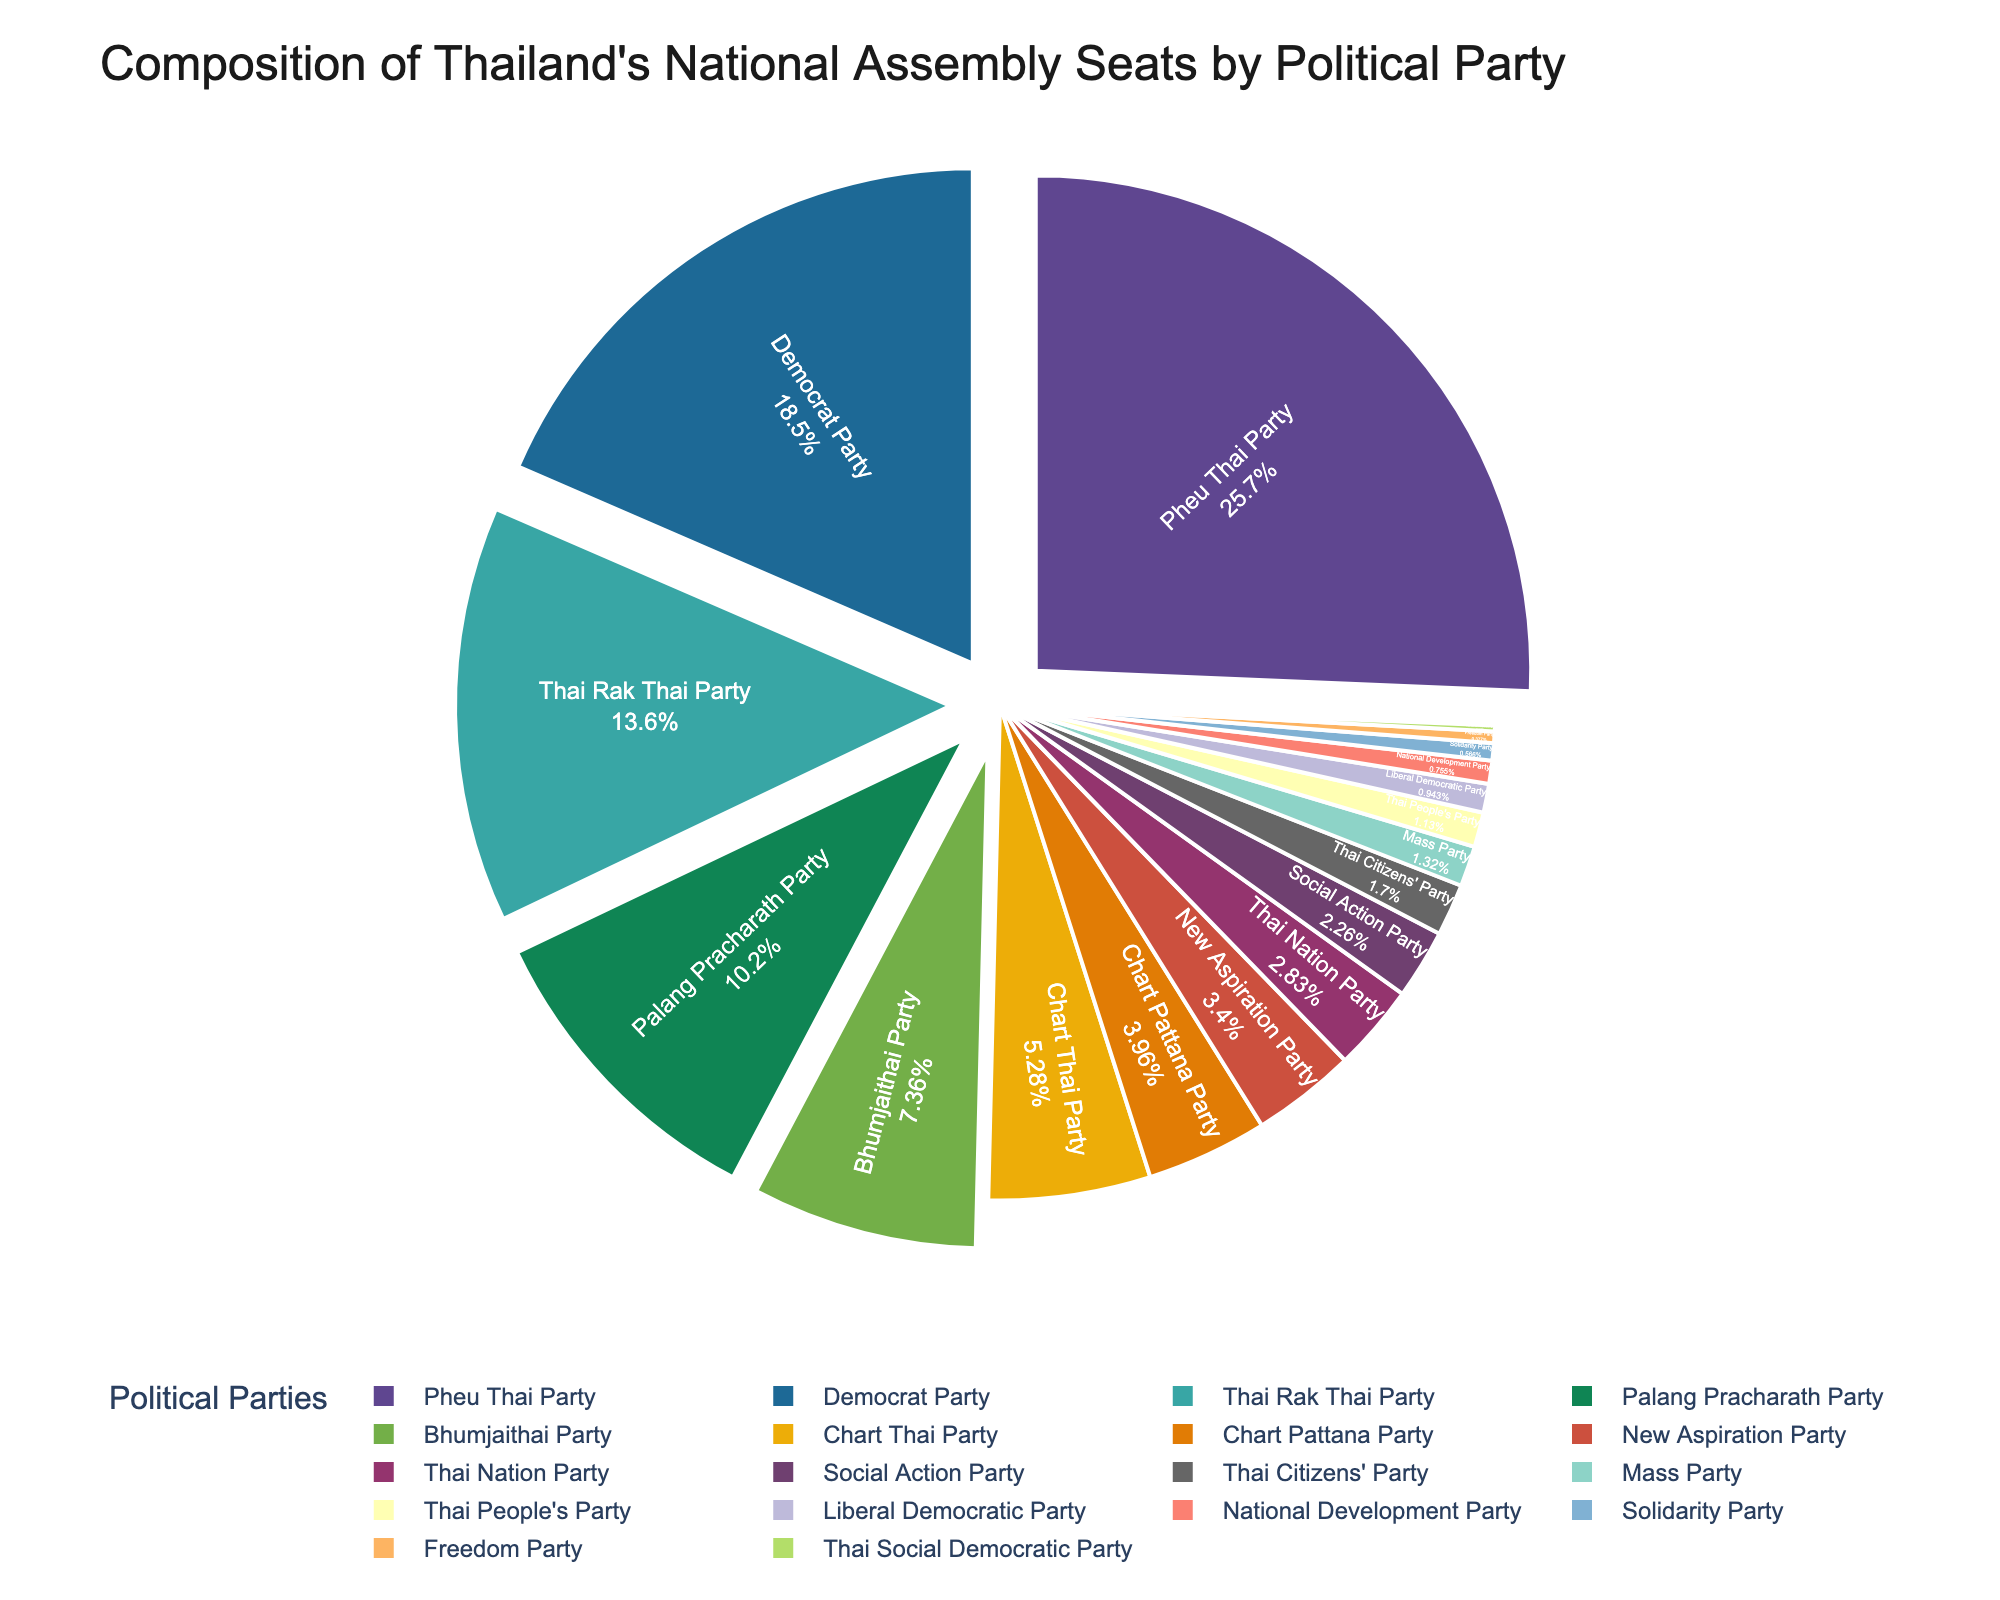What percentage of the National Assembly seats does the Pheu Thai Party hold? Pheu Thai Party holds 136 seats. Use the figure to find the percentage by comparing its slice to the whole. The percentage is represented in the pie-chart itself.
Answer: Approximately 31% Which party holds more seats, the Democrat Party or the Palang Pracharath Party? Compare the slices of the pie chart for the Democrat Party and the Palang Pracharath Party. The Democrat Party's slice is significantly larger than that of the Palang Pracharath Party.
Answer: Democrat Party How many more seats does the Pheu Thai Party hold compared to the Chart Thai Party? The Pheu Thai Party holds 136 seats, and the Chart Thai Party holds 28 seats. Subtract the number of seats of Chart Thai Party from Pheu Thai Party: 136 - 28 = 108.
Answer: 108 What is the combined percentage of seats held by the Thai Rak Thai Party and the Bhumjaithai Party? Sum the seats of Thai Rak Thai Party and Bhumjaithai Party, which are 72 and 39, respectively. Find their total percentage from the pie chart by adding their respective percentages.
Answer: Approximately 25% Are there more seats held by the top three parties combined compared to all the other parties? The top three parties are Pheu Thai Party, Democrat Party, and Thai Rak Thai Party, which together hold 136 + 98 + 72 = 306 seats. Sum the seats of all other parties (54, 39, 28, 21, 18, 15, 12, 9, 7, 6, 5, 4, 3, 2, 1) which total 224. Compare both sums. 306 is greater than 224.
Answer: Yes Which party holds the smallest number of seats, and what is that number? Look for the smallest slice in the pie chart. The Thai Social Democratic Party has the smallest slice, representing 1 seat.
Answer: Thai Social Democratic Party, 1 seat Does the Palang Pracharath Party hold more than twice the number of seats of the New Aspiration Party? Palang Pracharath Party holds 54 seats while New Aspiration Party holds 18 seats. Check if 54 is more than twice of 18: 18 * 2 = 36, and 54 is indeed more than 36.
Answer: Yes Are the total seats held by single-digit seat parties (Thai Citizens' Party, Mass Party, Thai People's Party, Liberal Democratic Party, National Development Party, Solidarity Party, Freedom Party, Thai Social Democratic Party) more or less than those held by the Bhumjaithai Party? Sum the seats of single-digit seat parties: 9 + 7 + 6 + 5 + 4 + 3 + 2 + 1 = 37. Compare it with the seats held by Bhumjaithai Party which is 39. Notice that 37 is less than 39.
Answer: Less How many parties hold fewer seats than the Chart Pattana Party? Identify parties with fewer seats than Chart Pattana Party (21 seats): New Aspiration Party (18), Thai Nation Party (15), Social Action Party (12), Thai Citizens' Party (9), Mass Party (7), Thai People's Party (6), Liberal Democratic Party (5), National Development Party (4), Solidarity Party (3), Freedom Party (2), Thai Social Democratic Party (1). Count them: There are 11 parties.
Answer: 11 